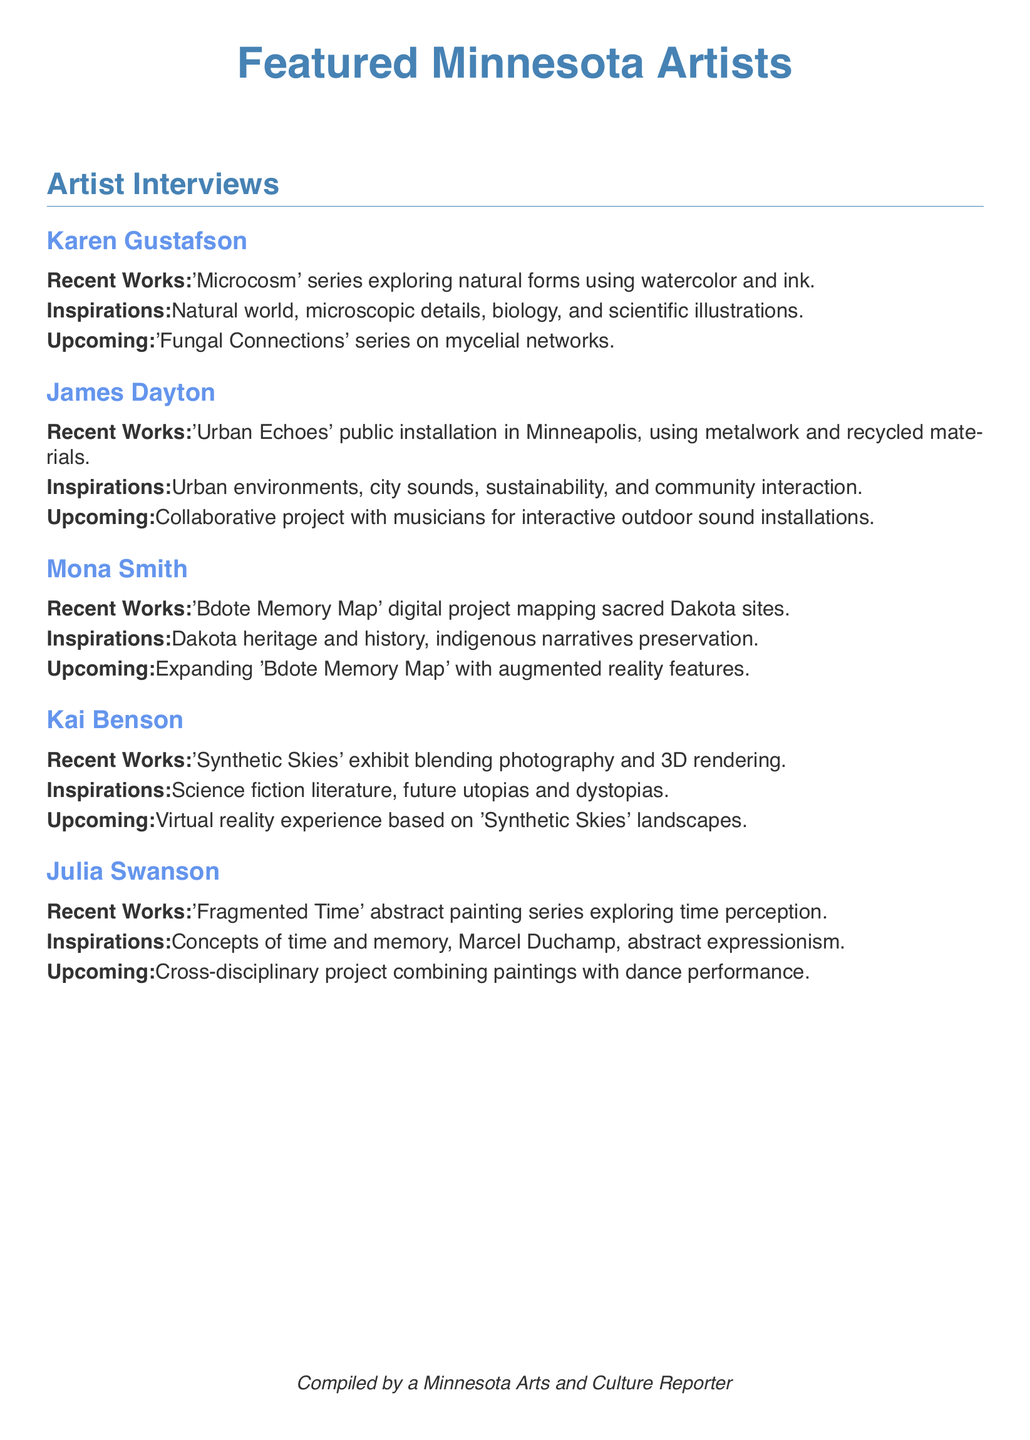What is the title of Karen Gustafson's recent work? The recent work is titled 'Microcosm' series, which is mentioned in her artist box.
Answer: 'Microcosm' series What is the upcoming project for James Dayton? The upcoming project mentioned is a collaborative project with musicians for interactive outdoor sound installations.
Answer: Collaborative project with musicians for interactive outdoor sound installations Which artist focuses on Dakota heritage and history? Mona Smith is known for her focus on Dakota heritage and history in her work.
Answer: Mona Smith What medium does Kai Benson use in his 'Synthetic Skies' exhibit? The medium used in the 'Synthetic Skies' exhibit is a blend of photography and 3D rendering, as referenced in his artist box.
Answer: Photography and 3D rendering What inspiration does Julia Swanson draw from for her current works? Julia Swanson draws her inspiration from concepts of time and memory, as stated in her artist box.
Answer: Concepts of time and memory How many artists are featured in the document? There are five artists featured in the document, as indicated by the individual artist boxes.
Answer: Five artists What is the theme of the 'Bdote Memory Map'? The theme revolves around mapping sacred Dakota sites, as mentioned in Mona Smith's section.
Answer: Sacred Dakota sites What type of project is being expanded with augmented reality features? The artist Mona Smith's project, 'Bdote Memory Map', is being expanded with augmented reality features.
Answer: 'Bdote Memory Map' What artistic movement does Julia Swanson reference? Julia Swanson references abstract expressionism in her inspirations.
Answer: Abstract expressionism 